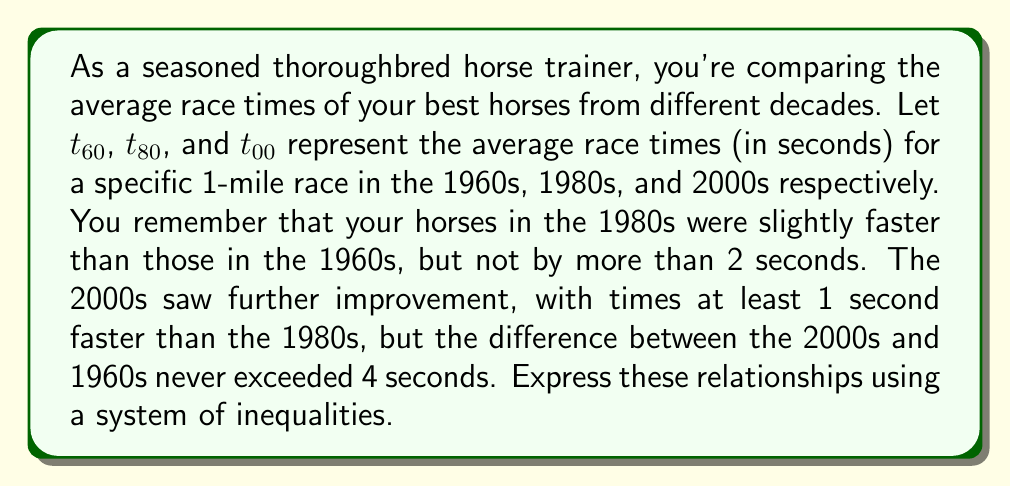Can you answer this question? Let's break down the information given and translate it into mathematical inequalities:

1. 1980s horses were slightly faster than 1960s horses, but not by more than 2 seconds:
   This means $t_{80}$ is less than $t_{60}$, but the difference is at most 2 seconds.
   We can express this as: $t_{60} - 2 \leq t_{80} < t_{60}$

2. 2000s horses were at least 1 second faster than 1980s horses:
   This can be written as: $t_{00} \leq t_{80} - 1$

3. The difference between 2000s and 1960s times never exceeded 4 seconds:
   This means: $t_{60} - 4 < t_{00}$

Combining these inequalities, we get the system:

$$\begin{cases}
t_{60} - 2 \leq t_{80} < t_{60} \\
t_{00} \leq t_{80} - 1 \\
t_{60} - 4 < t_{00}
\end{cases}$$

This system of inequalities represents the relationships between the average race times across the three decades, based on your recollections as an experienced horse trainer.
Answer: $$\begin{cases}
t_{60} - 2 \leq t_{80} < t_{60} \\
t_{00} \leq t_{80} - 1 \\
t_{60} - 4 < t_{00}
\end{cases}$$ 